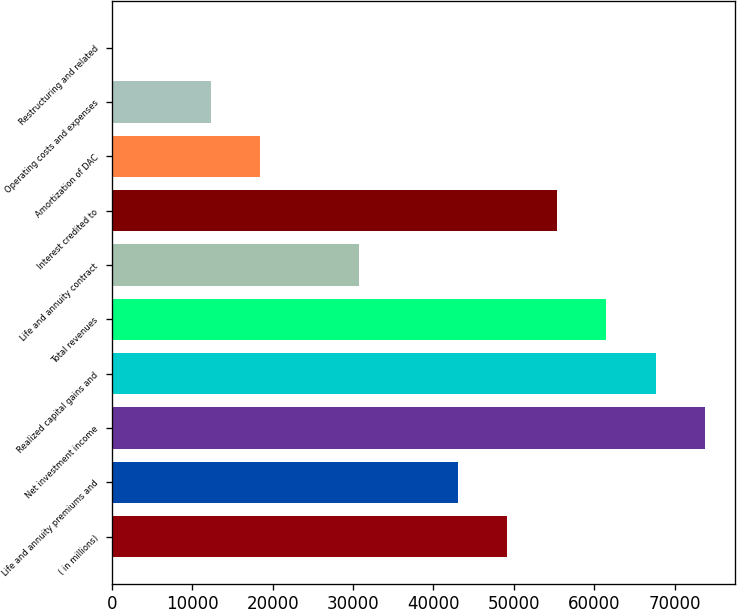Convert chart. <chart><loc_0><loc_0><loc_500><loc_500><bar_chart><fcel>( in millions)<fcel>Life and annuity premiums and<fcel>Net investment income<fcel>Realized capital gains and<fcel>Total revenues<fcel>Life and annuity contract<fcel>Interest credited to<fcel>Amortization of DAC<fcel>Operating costs and expenses<fcel>Restructuring and related<nl><fcel>49199.4<fcel>43049.6<fcel>73798.6<fcel>67648.8<fcel>61499<fcel>30750<fcel>55349.2<fcel>18450.4<fcel>12300.6<fcel>1<nl></chart> 